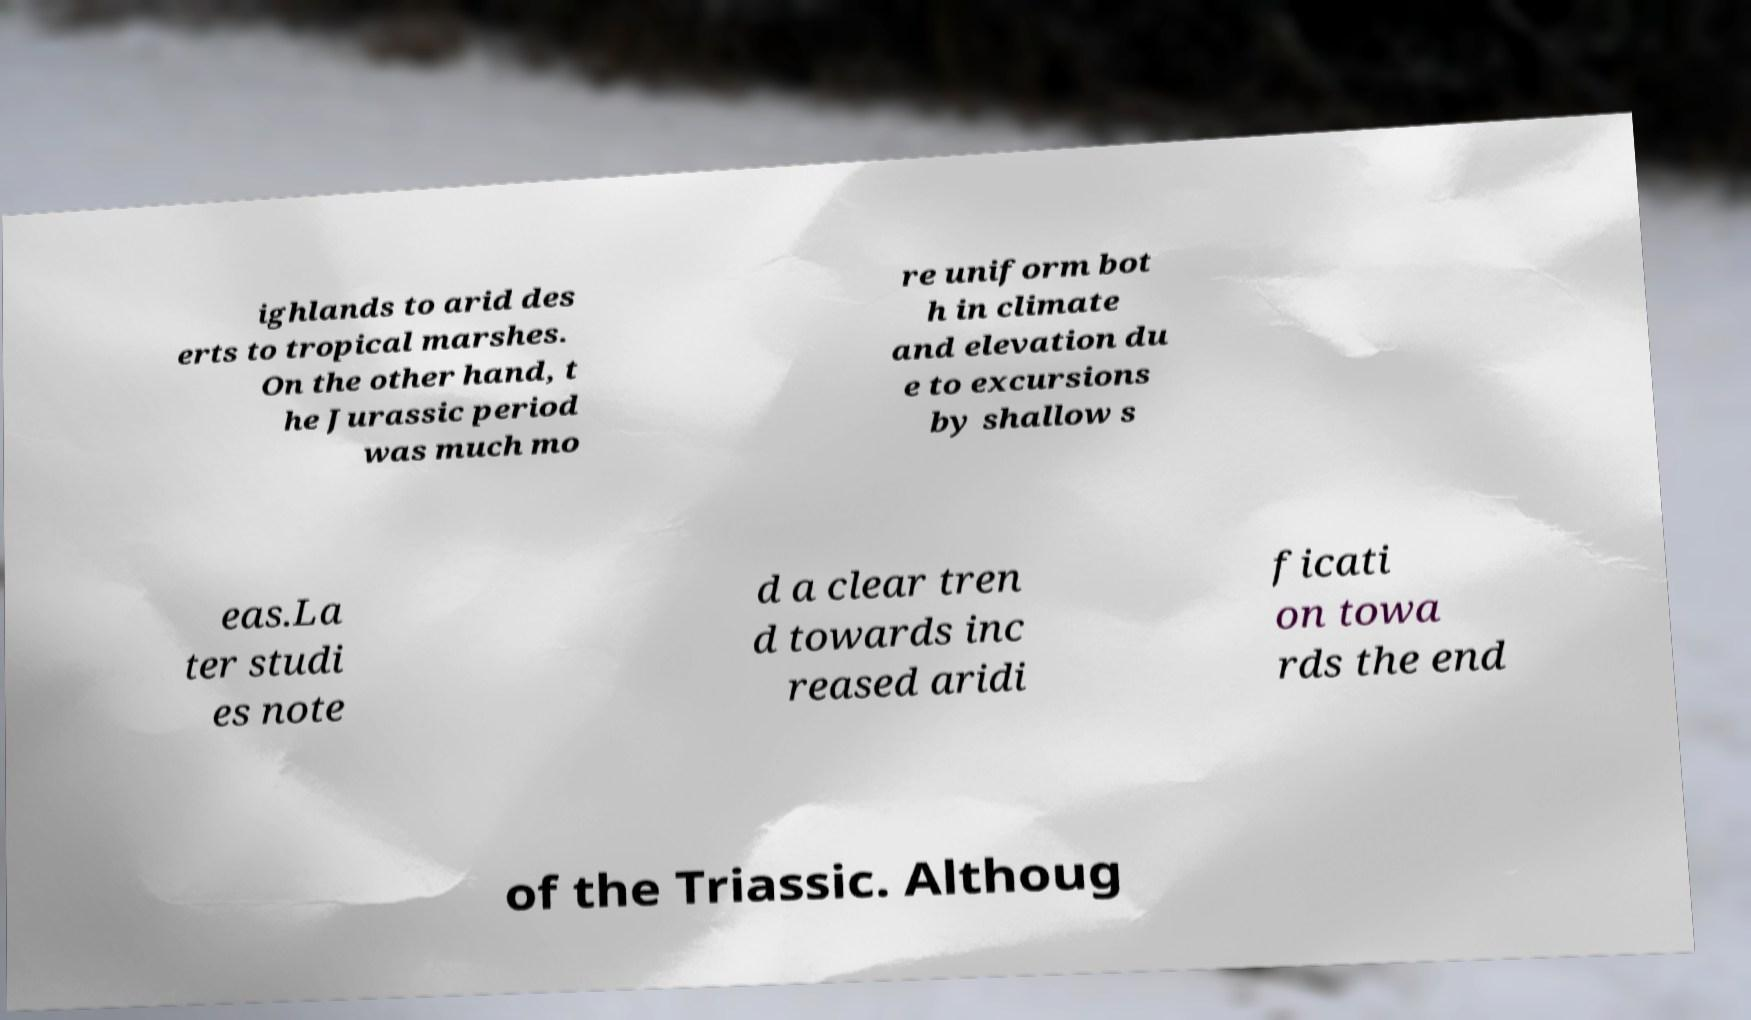Could you extract and type out the text from this image? ighlands to arid des erts to tropical marshes. On the other hand, t he Jurassic period was much mo re uniform bot h in climate and elevation du e to excursions by shallow s eas.La ter studi es note d a clear tren d towards inc reased aridi ficati on towa rds the end of the Triassic. Althoug 